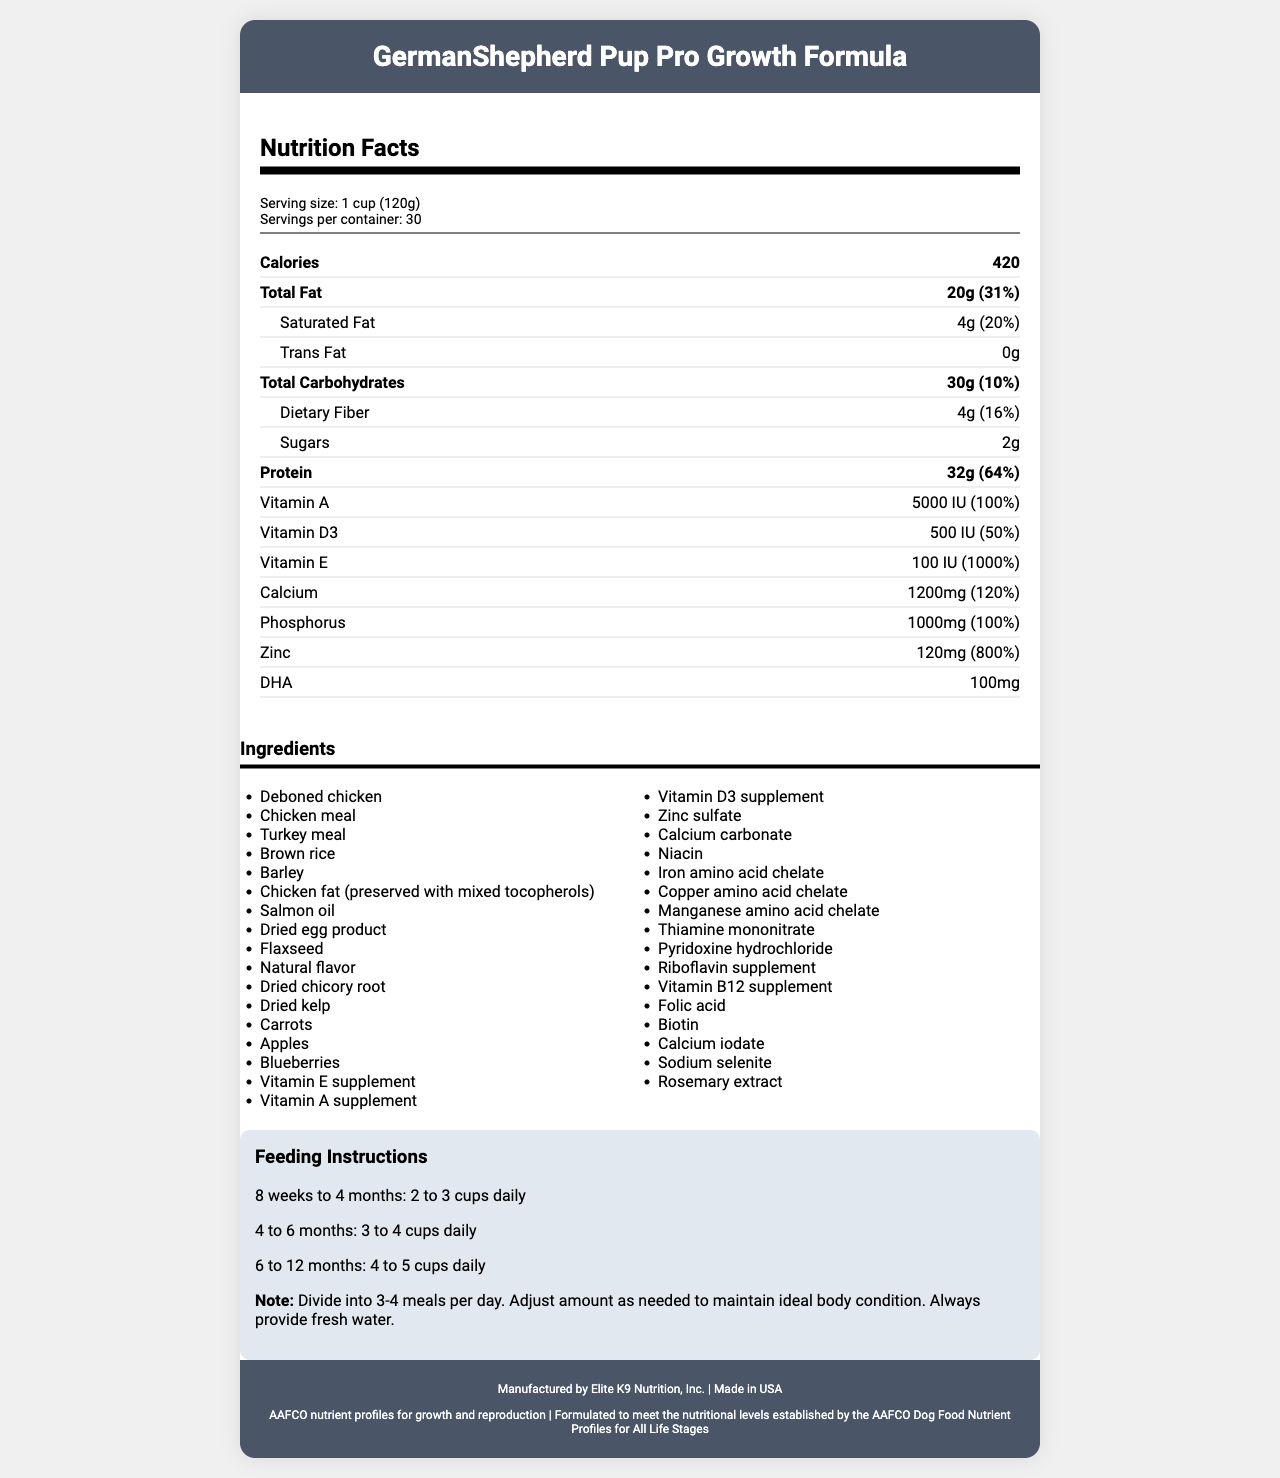what is the serving size? The document states that the serving size is 1 cup (120g).
Answer: 1 cup (120g) how many calories are in one serving? According to the document, each serving contains 420 calories.
Answer: 420 calories how much protein is in one serving? The document indicates that one serving contains 32 grams of protein.
Answer: 32 grams what is the percent daily value of protein per serving? The percent daily value of protein per serving is listed as 64%.
Answer: 64% what types of fats are listed and how much of each are in one serving? The document lists 20 grams of total fat, 4 grams of saturated fat, and 0 grams of trans fat per serving.
Answer: 20g total, 4g saturated, 0g trans what is the serving suggestion for puppies aged 8 weeks to 4 months? The feeding instructions indicate that puppies aged 8 weeks to 4 months should be fed 2 to 3 cups daily.
Answer: 2 to 3 cups daily which ingredient is listed first? The first ingredient listed in the ingredients section is "Deboned chicken."
Answer: Deboned chicken how many servings are in the container? The document states that there are 30 servings per container.
Answer: 30 servings which vitamins have a 100% daily value per serving? The document indicates that both Vitamin A and Vitamin E have a 100% daily value per serving.
Answer: Vitamin A and Vitamin E what are the main ingredients in the puppy food? A. Chicken, rice, wheat B. Deboned chicken, chicken meal, turkey meal, brown rice C. Beef, salmon, potatoes D. Salmon, duck, corn The document lists the main ingredients as Deboned chicken, Chicken meal, Turkey meal, and Brown rice.
Answer: B how much DHA is in the puppy food? A. 100mg B. 200mg C. 300mg D. 400mg The document specifies that there are 100mg of DHA in the puppy food.
Answer: A is the puppy food formulated for all life stages? According to the document, the puppy food is formulated to meet the nutritional levels established by the AAFCO Dog Food Nutrient Profiles for All Life Stages.
Answer: Yes what certifications does the product have? The document lists these certifications in the footer of the document.
Answer: AAFCO nutrient profiles for growth and reproduction, Formulated to meet the nutritional levels established by the AAFCO Dog Food Nutrient Profiles for All Life Stages describe the main points of this document. The document aims to inform the reader about the nutritional content, proper feeding amounts, and other relevant details of the puppy food.
Answer: The document provides detailed nutrition facts for "GermanShepherd Pup Pro Growth Formula," including serving size, calories, macronutrients, vitamins, and minerals. The ingredients, guaranteed analysis, feeding instructions for different puppy ages, storage guidelines, manufacturer information, and certifications are also included. what is the source of calcium in the ingredients list? The ingredient section lists Calcium carbonate as the source of calcium.
Answer: Calcium carbonate what is the omega-3 fatty acid content in the guaranteed analysis? The document's guaranteed analysis section states that the omega-3 fatty acids content is 0.5% minimum.
Answer: 0.5% min how should the puppy food be stored? The storage instructions advise storing the food in a cool, dry place and resealing the bag after opening to maintain freshness.
Answer: Store in a cool, dry place. Reseal bag after opening to preserve freshness. how much glucosamine is in the guaranteed analysis? The guaranteed analysis specifies that there is a minimum of 750 mg/kg of glucosamine in the food.
Answer: 750 mg/kg min 